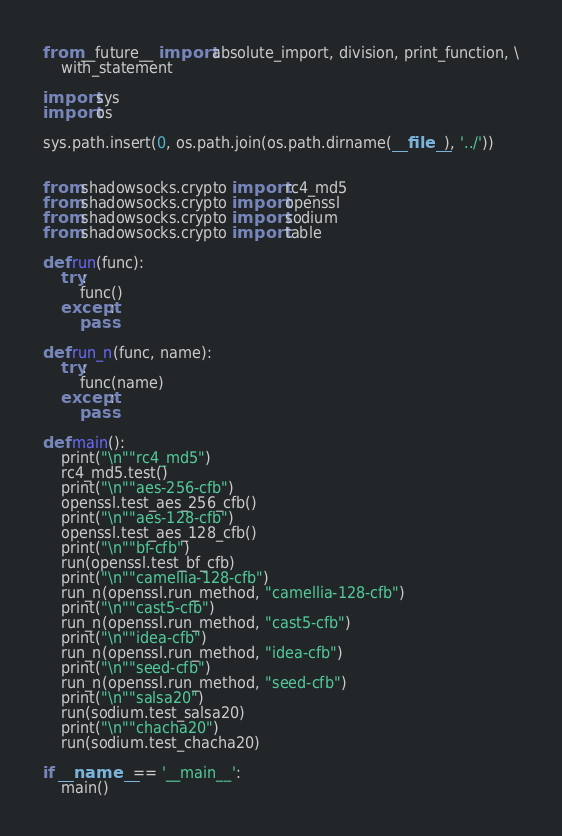Convert code to text. <code><loc_0><loc_0><loc_500><loc_500><_Python_>from __future__ import absolute_import, division, print_function, \
    with_statement

import sys
import os

sys.path.insert(0, os.path.join(os.path.dirname(__file__), '../'))


from shadowsocks.crypto import rc4_md5
from shadowsocks.crypto import openssl
from shadowsocks.crypto import sodium
from shadowsocks.crypto import table

def run(func):
	try:
		func()
	except:
		pass

def run_n(func, name):
	try:
		func(name)
	except:
		pass

def main():
	print("\n""rc4_md5")
	rc4_md5.test()
	print("\n""aes-256-cfb")
	openssl.test_aes_256_cfb()
	print("\n""aes-128-cfb")
	openssl.test_aes_128_cfb()
	print("\n""bf-cfb")
	run(openssl.test_bf_cfb)
	print("\n""camellia-128-cfb")
	run_n(openssl.run_method, "camellia-128-cfb")
	print("\n""cast5-cfb")
	run_n(openssl.run_method, "cast5-cfb")
	print("\n""idea-cfb")
	run_n(openssl.run_method, "idea-cfb")
	print("\n""seed-cfb")
	run_n(openssl.run_method, "seed-cfb")
	print("\n""salsa20")
	run(sodium.test_salsa20)
	print("\n""chacha20")
	run(sodium.test_chacha20)

if __name__ == '__main__':
	main()

</code> 